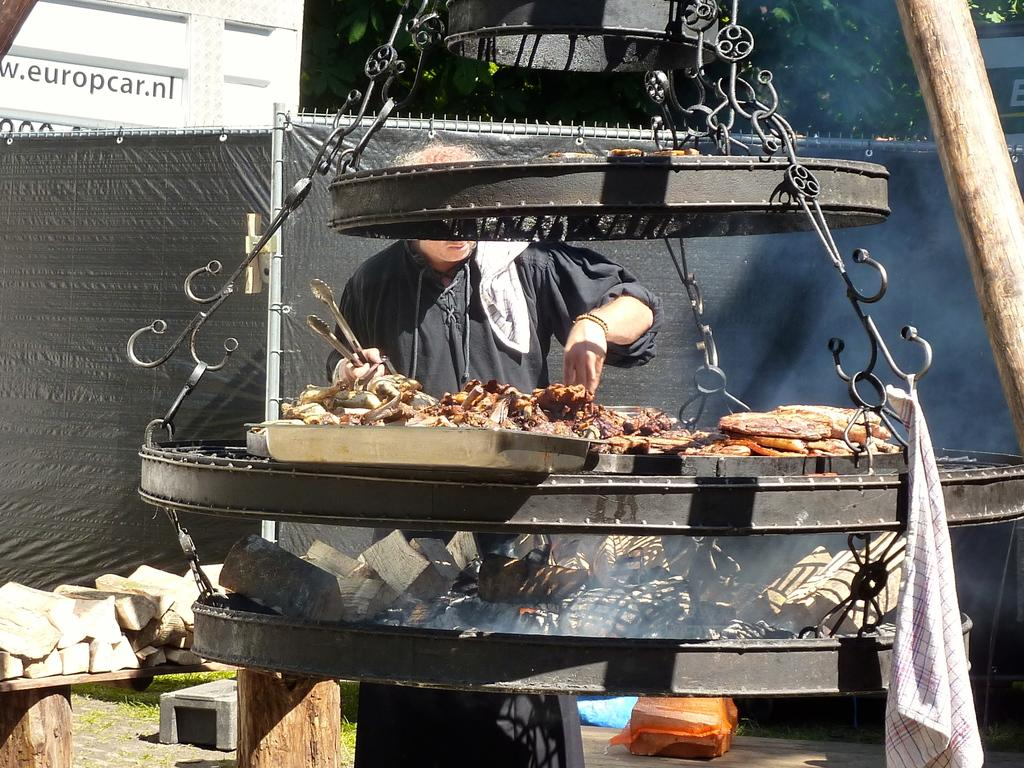<image>
Give a short and clear explanation of the subsequent image. A man cooking in front of a wall with a website url for europcar. 